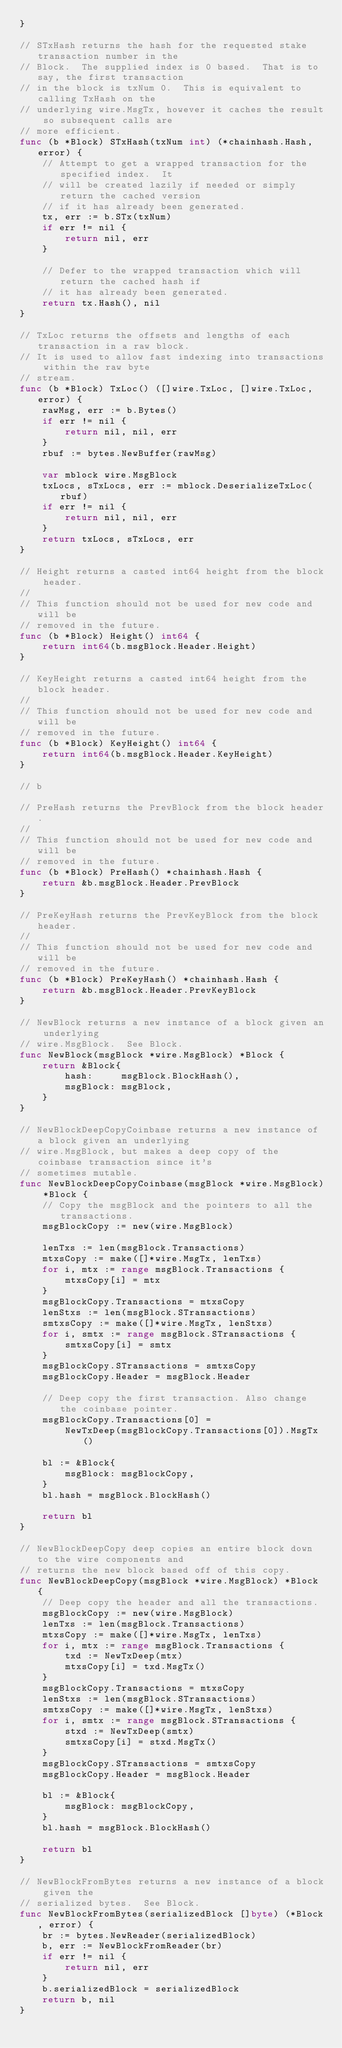<code> <loc_0><loc_0><loc_500><loc_500><_Go_>}

// STxHash returns the hash for the requested stake transaction number in the
// Block.  The supplied index is 0 based.  That is to say, the first transaction
// in the block is txNum 0.  This is equivalent to calling TxHash on the
// underlying wire.MsgTx, however it caches the result so subsequent calls are
// more efficient.
func (b *Block) STxHash(txNum int) (*chainhash.Hash, error) {
	// Attempt to get a wrapped transaction for the specified index.  It
	// will be created lazily if needed or simply return the cached version
	// if it has already been generated.
	tx, err := b.STx(txNum)
	if err != nil {
		return nil, err
	}

	// Defer to the wrapped transaction which will return the cached hash if
	// it has already been generated.
	return tx.Hash(), nil
}

// TxLoc returns the offsets and lengths of each transaction in a raw block.
// It is used to allow fast indexing into transactions within the raw byte
// stream.
func (b *Block) TxLoc() ([]wire.TxLoc, []wire.TxLoc, error) {
	rawMsg, err := b.Bytes()
	if err != nil {
		return nil, nil, err
	}
	rbuf := bytes.NewBuffer(rawMsg)

	var mblock wire.MsgBlock
	txLocs, sTxLocs, err := mblock.DeserializeTxLoc(rbuf)
	if err != nil {
		return nil, nil, err
	}
	return txLocs, sTxLocs, err
}

// Height returns a casted int64 height from the block header.
//
// This function should not be used for new code and will be
// removed in the future.
func (b *Block) Height() int64 {
	return int64(b.msgBlock.Header.Height)
}

// KeyHeight returns a casted int64 height from the block header.
//
// This function should not be used for new code and will be
// removed in the future.
func (b *Block) KeyHeight() int64 {
	return int64(b.msgBlock.Header.KeyHeight)
}

// b

// PreHash returns the PrevBlock from the block header.
//
// This function should not be used for new code and will be
// removed in the future.
func (b *Block) PreHash() *chainhash.Hash {
	return &b.msgBlock.Header.PrevBlock
}

// PreKeyHash returns the PrevKeyBlock from the block header.
//
// This function should not be used for new code and will be
// removed in the future.
func (b *Block) PreKeyHash() *chainhash.Hash {
	return &b.msgBlock.Header.PrevKeyBlock
}

// NewBlock returns a new instance of a block given an underlying
// wire.MsgBlock.  See Block.
func NewBlock(msgBlock *wire.MsgBlock) *Block {
	return &Block{
		hash:     msgBlock.BlockHash(),
		msgBlock: msgBlock,
	}
}

// NewBlockDeepCopyCoinbase returns a new instance of a block given an underlying
// wire.MsgBlock, but makes a deep copy of the coinbase transaction since it's
// sometimes mutable.
func NewBlockDeepCopyCoinbase(msgBlock *wire.MsgBlock) *Block {
	// Copy the msgBlock and the pointers to all the transactions.
	msgBlockCopy := new(wire.MsgBlock)

	lenTxs := len(msgBlock.Transactions)
	mtxsCopy := make([]*wire.MsgTx, lenTxs)
	for i, mtx := range msgBlock.Transactions {
		mtxsCopy[i] = mtx
	}
	msgBlockCopy.Transactions = mtxsCopy
	lenStxs := len(msgBlock.STransactions)
	smtxsCopy := make([]*wire.MsgTx, lenStxs)
	for i, smtx := range msgBlock.STransactions {
		smtxsCopy[i] = smtx
	}
	msgBlockCopy.STransactions = smtxsCopy
	msgBlockCopy.Header = msgBlock.Header

	// Deep copy the first transaction. Also change the coinbase pointer.
	msgBlockCopy.Transactions[0] =
		NewTxDeep(msgBlockCopy.Transactions[0]).MsgTx()

	bl := &Block{
		msgBlock: msgBlockCopy,
	}
	bl.hash = msgBlock.BlockHash()

	return bl
}

// NewBlockDeepCopy deep copies an entire block down to the wire components and
// returns the new block based off of this copy.
func NewBlockDeepCopy(msgBlock *wire.MsgBlock) *Block {
	// Deep copy the header and all the transactions.
	msgBlockCopy := new(wire.MsgBlock)
	lenTxs := len(msgBlock.Transactions)
	mtxsCopy := make([]*wire.MsgTx, lenTxs)
	for i, mtx := range msgBlock.Transactions {
		txd := NewTxDeep(mtx)
		mtxsCopy[i] = txd.MsgTx()
	}
	msgBlockCopy.Transactions = mtxsCopy
	lenStxs := len(msgBlock.STransactions)
	smtxsCopy := make([]*wire.MsgTx, lenStxs)
	for i, smtx := range msgBlock.STransactions {
		stxd := NewTxDeep(smtx)
		smtxsCopy[i] = stxd.MsgTx()
	}
	msgBlockCopy.STransactions = smtxsCopy
	msgBlockCopy.Header = msgBlock.Header

	bl := &Block{
		msgBlock: msgBlockCopy,
	}
	bl.hash = msgBlock.BlockHash()

	return bl
}

// NewBlockFromBytes returns a new instance of a block given the
// serialized bytes.  See Block.
func NewBlockFromBytes(serializedBlock []byte) (*Block, error) {
	br := bytes.NewReader(serializedBlock)
	b, err := NewBlockFromReader(br)
	if err != nil {
		return nil, err
	}
	b.serializedBlock = serializedBlock
	return b, nil
}
</code> 